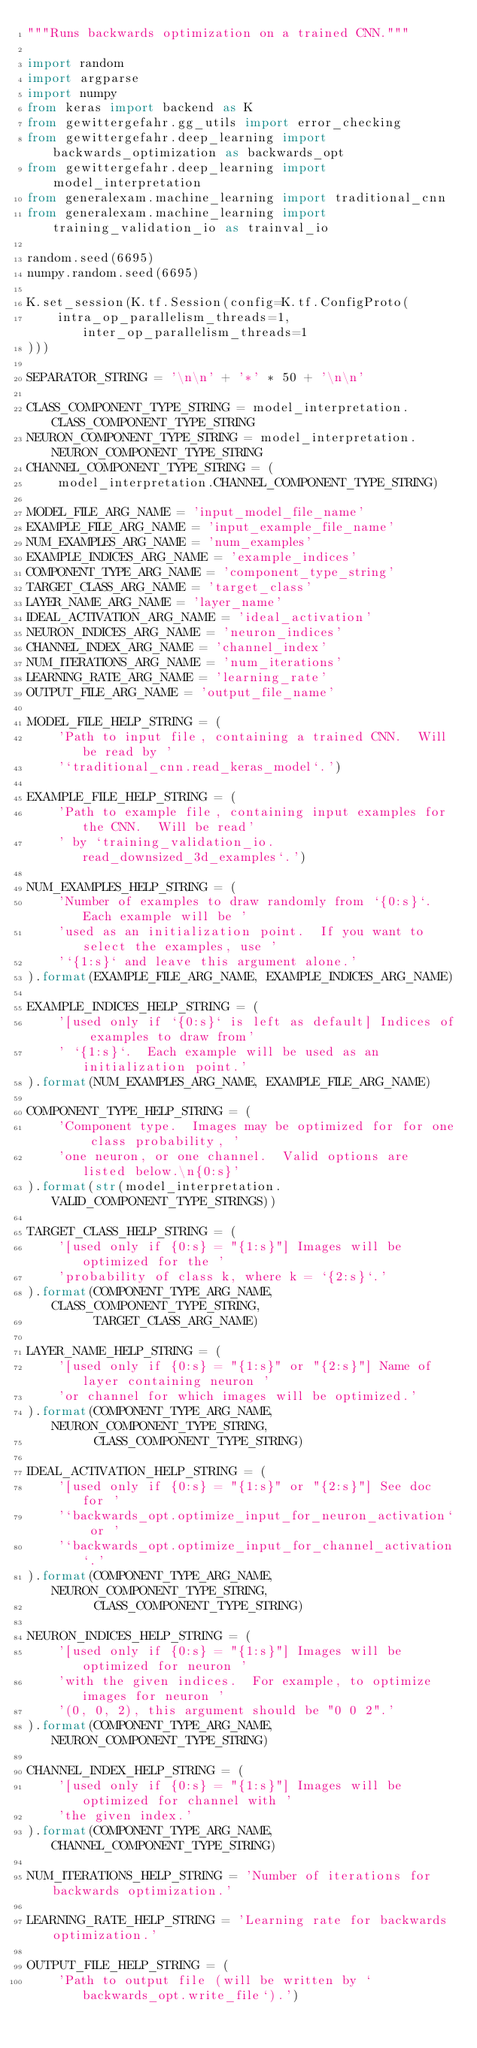<code> <loc_0><loc_0><loc_500><loc_500><_Python_>"""Runs backwards optimization on a trained CNN."""

import random
import argparse
import numpy
from keras import backend as K
from gewittergefahr.gg_utils import error_checking
from gewittergefahr.deep_learning import backwards_optimization as backwards_opt
from gewittergefahr.deep_learning import model_interpretation
from generalexam.machine_learning import traditional_cnn
from generalexam.machine_learning import training_validation_io as trainval_io

random.seed(6695)
numpy.random.seed(6695)

K.set_session(K.tf.Session(config=K.tf.ConfigProto(
    intra_op_parallelism_threads=1, inter_op_parallelism_threads=1
)))

SEPARATOR_STRING = '\n\n' + '*' * 50 + '\n\n'

CLASS_COMPONENT_TYPE_STRING = model_interpretation.CLASS_COMPONENT_TYPE_STRING
NEURON_COMPONENT_TYPE_STRING = model_interpretation.NEURON_COMPONENT_TYPE_STRING
CHANNEL_COMPONENT_TYPE_STRING = (
    model_interpretation.CHANNEL_COMPONENT_TYPE_STRING)

MODEL_FILE_ARG_NAME = 'input_model_file_name'
EXAMPLE_FILE_ARG_NAME = 'input_example_file_name'
NUM_EXAMPLES_ARG_NAME = 'num_examples'
EXAMPLE_INDICES_ARG_NAME = 'example_indices'
COMPONENT_TYPE_ARG_NAME = 'component_type_string'
TARGET_CLASS_ARG_NAME = 'target_class'
LAYER_NAME_ARG_NAME = 'layer_name'
IDEAL_ACTIVATION_ARG_NAME = 'ideal_activation'
NEURON_INDICES_ARG_NAME = 'neuron_indices'
CHANNEL_INDEX_ARG_NAME = 'channel_index'
NUM_ITERATIONS_ARG_NAME = 'num_iterations'
LEARNING_RATE_ARG_NAME = 'learning_rate'
OUTPUT_FILE_ARG_NAME = 'output_file_name'

MODEL_FILE_HELP_STRING = (
    'Path to input file, containing a trained CNN.  Will be read by '
    '`traditional_cnn.read_keras_model`.')

EXAMPLE_FILE_HELP_STRING = (
    'Path to example file, containing input examples for the CNN.  Will be read'
    ' by `training_validation_io.read_downsized_3d_examples`.')

NUM_EXAMPLES_HELP_STRING = (
    'Number of examples to draw randomly from `{0:s}`.  Each example will be '
    'used as an initialization point.  If you want to select the examples, use '
    '`{1:s}` and leave this argument alone.'
).format(EXAMPLE_FILE_ARG_NAME, EXAMPLE_INDICES_ARG_NAME)

EXAMPLE_INDICES_HELP_STRING = (
    '[used only if `{0:s}` is left as default] Indices of examples to draw from'
    ' `{1:s}`.  Each example will be used as an initialization point.'
).format(NUM_EXAMPLES_ARG_NAME, EXAMPLE_FILE_ARG_NAME)

COMPONENT_TYPE_HELP_STRING = (
    'Component type.  Images may be optimized for for one class probability, '
    'one neuron, or one channel.  Valid options are listed below.\n{0:s}'
).format(str(model_interpretation.VALID_COMPONENT_TYPE_STRINGS))

TARGET_CLASS_HELP_STRING = (
    '[used only if {0:s} = "{1:s}"] Images will be optimized for the '
    'probability of class k, where k = `{2:s}`.'
).format(COMPONENT_TYPE_ARG_NAME, CLASS_COMPONENT_TYPE_STRING,
         TARGET_CLASS_ARG_NAME)

LAYER_NAME_HELP_STRING = (
    '[used only if {0:s} = "{1:s}" or "{2:s}"] Name of layer containing neuron '
    'or channel for which images will be optimized.'
).format(COMPONENT_TYPE_ARG_NAME, NEURON_COMPONENT_TYPE_STRING,
         CLASS_COMPONENT_TYPE_STRING)

IDEAL_ACTIVATION_HELP_STRING = (
    '[used only if {0:s} = "{1:s}" or "{2:s}"] See doc for '
    '`backwards_opt.optimize_input_for_neuron_activation` or '
    '`backwards_opt.optimize_input_for_channel_activation`.'
).format(COMPONENT_TYPE_ARG_NAME, NEURON_COMPONENT_TYPE_STRING,
         CLASS_COMPONENT_TYPE_STRING)

NEURON_INDICES_HELP_STRING = (
    '[used only if {0:s} = "{1:s}"] Images will be optimized for neuron '
    'with the given indices.  For example, to optimize images for neuron '
    '(0, 0, 2), this argument should be "0 0 2".'
).format(COMPONENT_TYPE_ARG_NAME, NEURON_COMPONENT_TYPE_STRING)

CHANNEL_INDEX_HELP_STRING = (
    '[used only if {0:s} = "{1:s}"] Images will be optimized for channel with '
    'the given index.'
).format(COMPONENT_TYPE_ARG_NAME, CHANNEL_COMPONENT_TYPE_STRING)

NUM_ITERATIONS_HELP_STRING = 'Number of iterations for backwards optimization.'

LEARNING_RATE_HELP_STRING = 'Learning rate for backwards optimization.'

OUTPUT_FILE_HELP_STRING = (
    'Path to output file (will be written by `backwards_opt.write_file`).')
</code> 